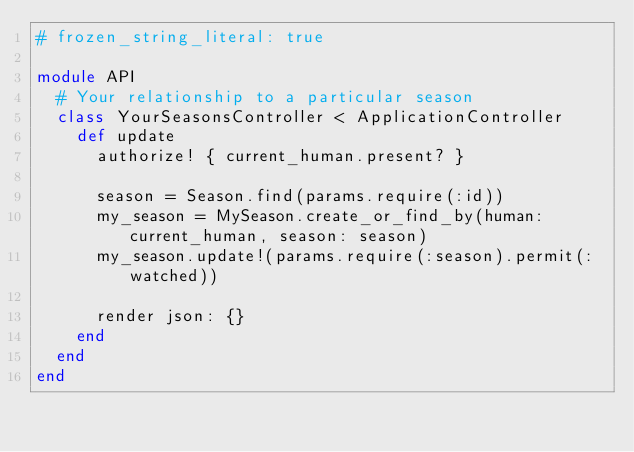<code> <loc_0><loc_0><loc_500><loc_500><_Ruby_># frozen_string_literal: true

module API
  # Your relationship to a particular season
  class YourSeasonsController < ApplicationController
    def update
      authorize! { current_human.present? }

      season = Season.find(params.require(:id))
      my_season = MySeason.create_or_find_by(human: current_human, season: season)
      my_season.update!(params.require(:season).permit(:watched))

      render json: {}
    end
  end
end
</code> 